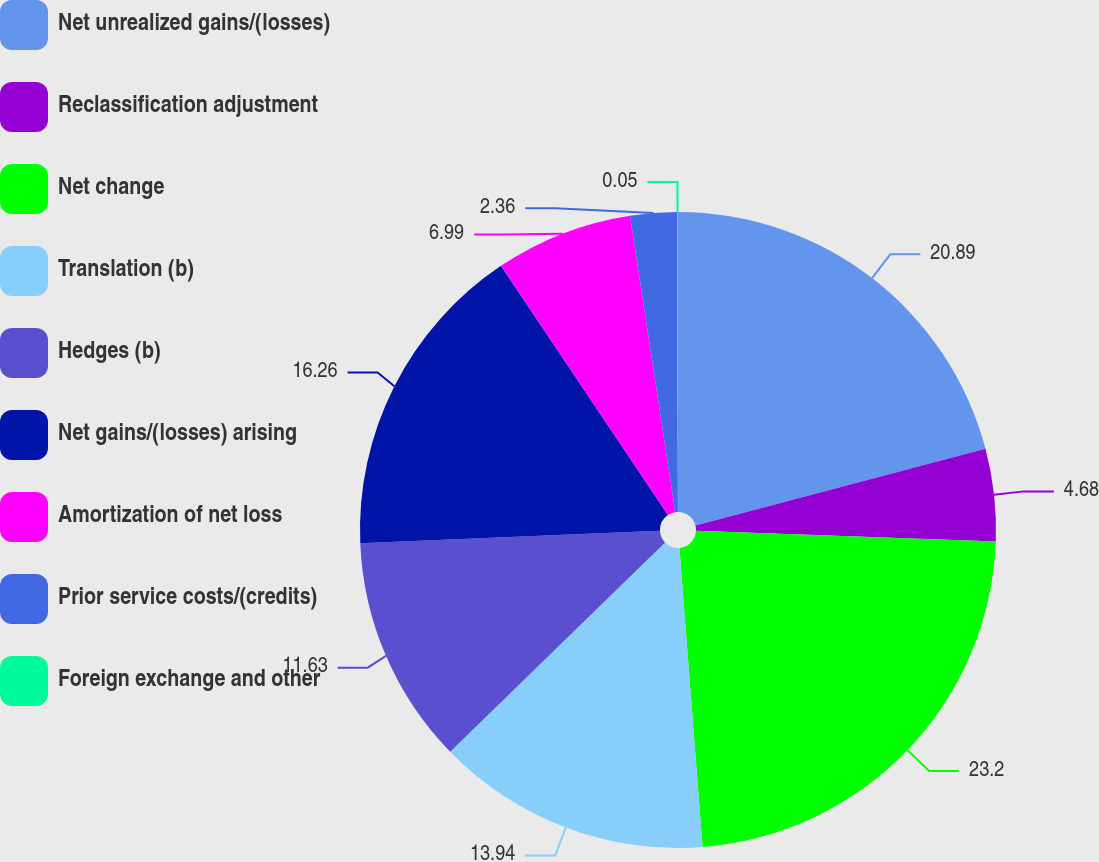<chart> <loc_0><loc_0><loc_500><loc_500><pie_chart><fcel>Net unrealized gains/(losses)<fcel>Reclassification adjustment<fcel>Net change<fcel>Translation (b)<fcel>Hedges (b)<fcel>Net gains/(losses) arising<fcel>Amortization of net loss<fcel>Prior service costs/(credits)<fcel>Foreign exchange and other<nl><fcel>20.89%<fcel>4.68%<fcel>23.2%<fcel>13.94%<fcel>11.63%<fcel>16.26%<fcel>6.99%<fcel>2.36%<fcel>0.05%<nl></chart> 